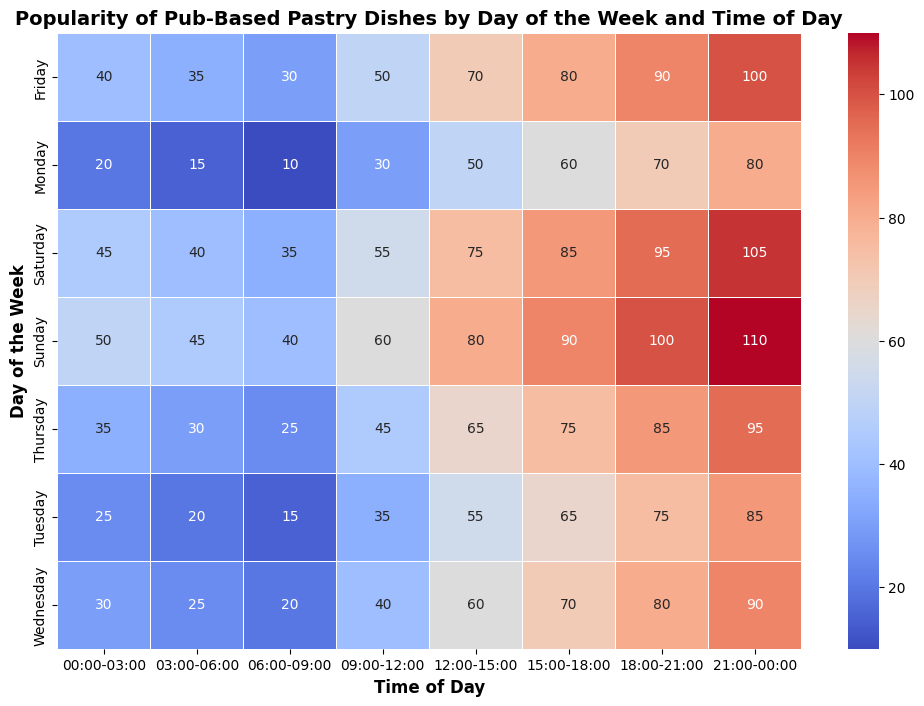Which day has the highest overall popularity of pub-based pastry dishes? Summing the popularity values for each day, we see Sunday has the highest total. The sum for Sunday is (50 + 45 + 40 + 60 + 80 + 90 + 100 + 110) = 575.
Answer: Sunday What time slot shows the peak popularity for pub-based pastry dishes on Saturday? Looking at the values for Saturday, the highest number is 105, which corresponds to the 21:00-00:00 time slot.
Answer: 21:00-00:00 Which day of the week has the lowest popularity during the early morning hours (00:00-03:00)? Comparing the popularity values for the 00:00-03:00 slot, Monday has the lowest value at 20.
Answer: Monday How does the popularity of pub-based pastry dishes on Wednesday at 15:00-18:00 compare to Friday at the same time? The popularity on Wednesday at 15:00-18:00 is 70, whereas on Friday at the same time it's 80. Since 70 is less than 80, Friday is more popular.
Answer: Friday is more popular What is the total popularity for Thursday from 12:00 to 18:00? Summing values for the 12:00-15:00 (65) and 15:00-18:00 (75) time slots for Thursday gives us 65 + 75 = 140.
Answer: 140 When is the most popular time slot for pub-based pastry dishes on any given day? The maximum value in the heatmap is 110, which occurs on Sunday from 21:00 to 00:00.
Answer: Sunday 21:00-00:00 What is the difference in popularity between Monday at 09:00-12:00 and Tuesday at 09:00-12:00? On Monday, the popularity is 30 at 09:00-12:00, and on Tuesday, it's 35 at the same time. The difference is 35 - 30 = 5.
Answer: 5 How does the overall popularity trend change from Monday to Sunday during the 18:00-21:00 time slot? From Monday to Sunday, the popularity values are: Monday (70), Tuesday (75), Wednesday (80), Thursday (85), Friday (90), Saturday (95), and Sunday (100). There is a consistent increase each day.
Answer: Consistently increases What time of day generally has the highest popularity regardless of the day? Looking at all days, the time slot 21:00-00:00 consistently has the highest popularity values across many days.
Answer: 21:00-00:00 